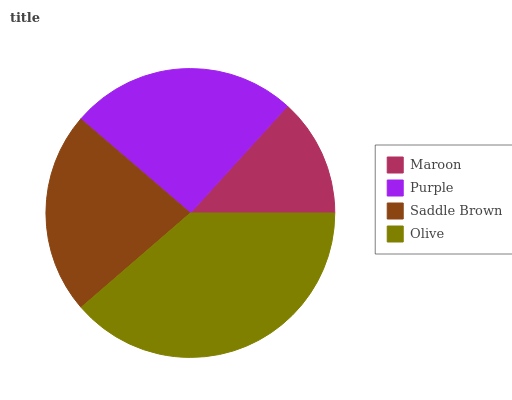Is Maroon the minimum?
Answer yes or no. Yes. Is Olive the maximum?
Answer yes or no. Yes. Is Purple the minimum?
Answer yes or no. No. Is Purple the maximum?
Answer yes or no. No. Is Purple greater than Maroon?
Answer yes or no. Yes. Is Maroon less than Purple?
Answer yes or no. Yes. Is Maroon greater than Purple?
Answer yes or no. No. Is Purple less than Maroon?
Answer yes or no. No. Is Purple the high median?
Answer yes or no. Yes. Is Saddle Brown the low median?
Answer yes or no. Yes. Is Saddle Brown the high median?
Answer yes or no. No. Is Purple the low median?
Answer yes or no. No. 